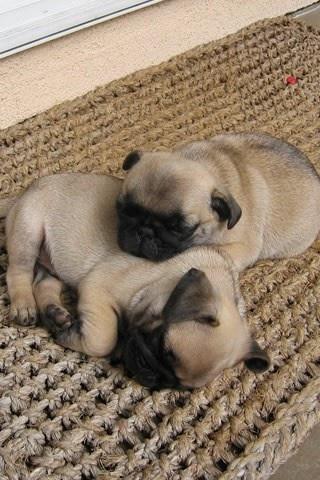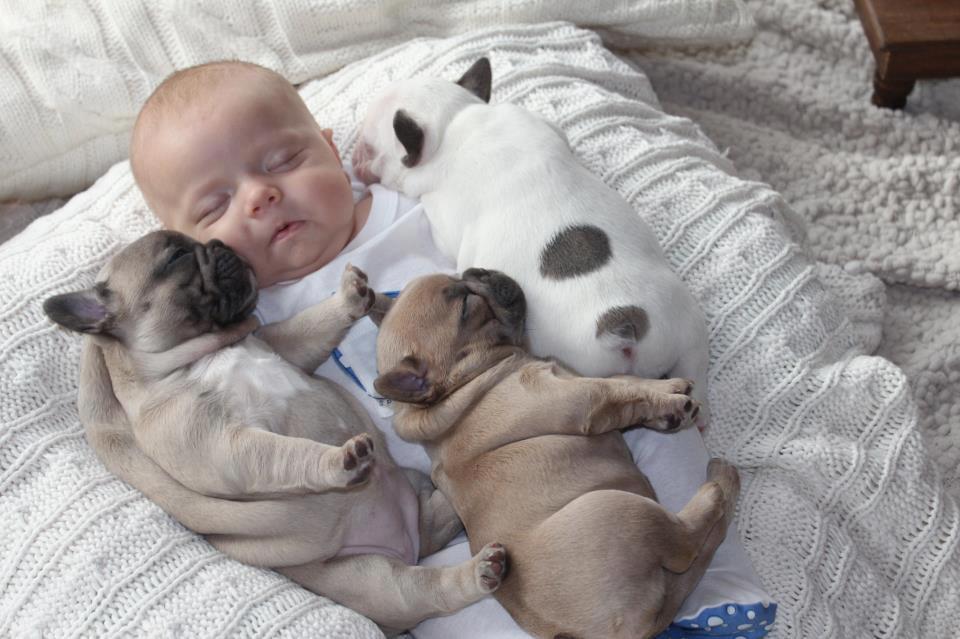The first image is the image on the left, the second image is the image on the right. Given the left and right images, does the statement "An image shows two beige pug pups and a white spotted pug pup sleeping on top of a sleeping human baby." hold true? Answer yes or no. Yes. The first image is the image on the left, the second image is the image on the right. Considering the images on both sides, is "The dogs in one of the images are sleeping on a baby." valid? Answer yes or no. Yes. 